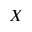<formula> <loc_0><loc_0><loc_500><loc_500>X</formula> 